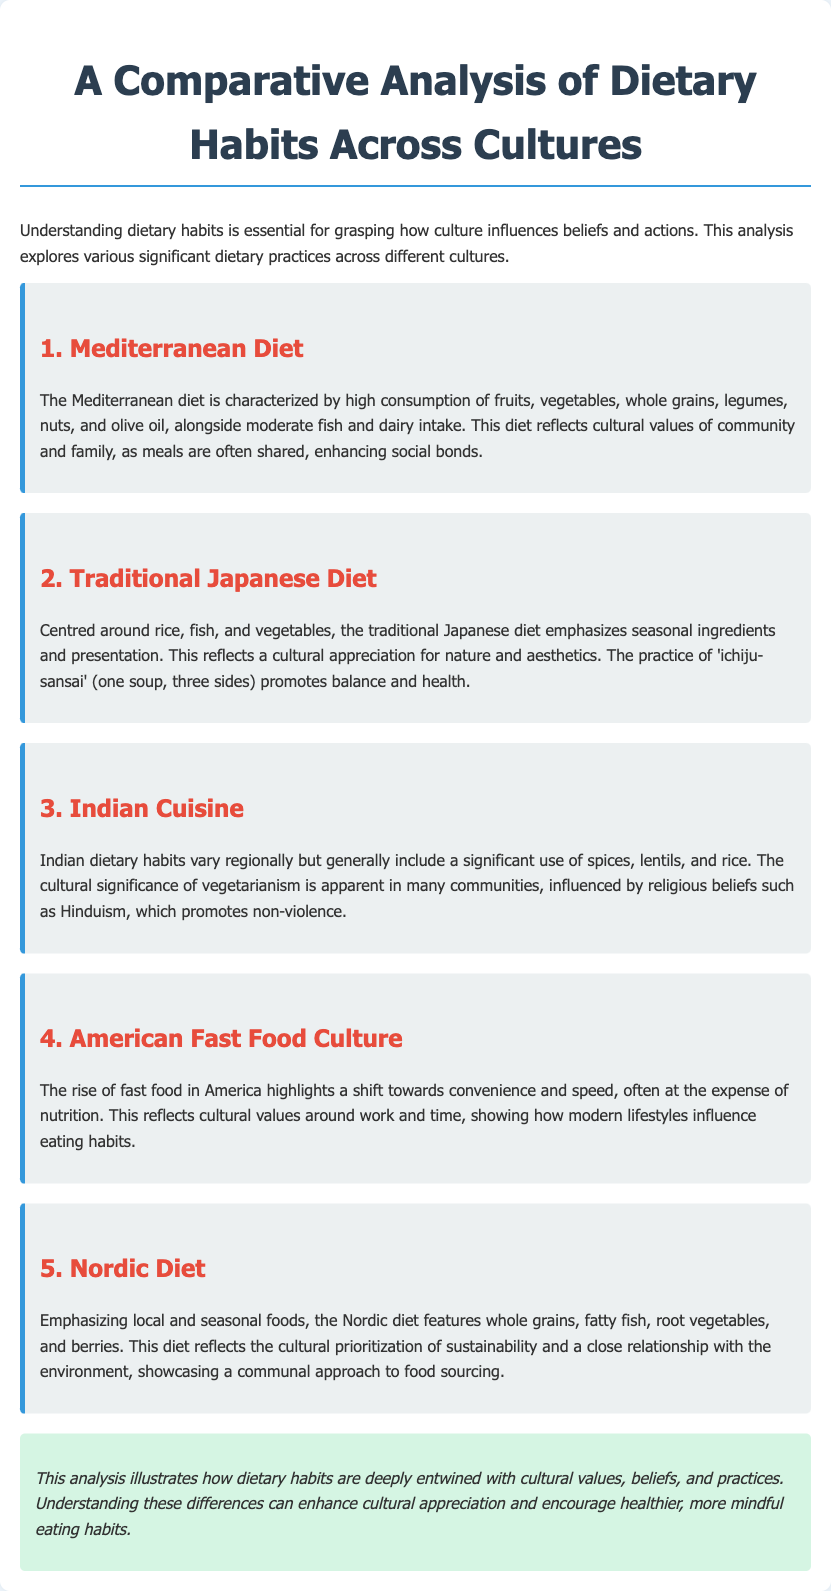what is the main focus of the document? The document analyzes how dietary habits are influenced by culture.
Answer: cultural influence on dietary habits what are the key components of the Mediterranean diet? The Mediterranean diet includes fruits, vegetables, whole grains, legumes, nuts, and olive oil.
Answer: fruits, vegetables, whole grains, legumes, nuts, olive oil what is 'ichiju-sansai' in the context of the Japanese diet? 'ichiju-sansai' refers to the practice of one soup and three sides in Japanese meals.
Answer: one soup, three sides how does the American fast food culture reflect societal values? It reflects a shift towards convenience and speed, highlighting work and time values.
Answer: convenience and speed which dietary practice is prominent in many Indian communities? Vegetarianism is a significant dietary practice influenced by religious beliefs.
Answer: vegetarianism what does the Nordic diet emphasize in terms of food sourcing? The Nordic diet emphasizes local and seasonal foods.
Answer: local and seasonal foods how are meals in the Mediterranean diet perceived culturally? Meals are often shared, enhancing social bonds.
Answer: shared meals who is influenced by the cultural significance of non-violence in dietary choices? Many Indian communities influenced by Hinduism practice vegetarianism.
Answer: Hinduism what do the dietary habits across cultures illustrate about societal beliefs? They illustrate deep entwinement with cultural values, beliefs, and practices.
Answer: cultural values and beliefs 